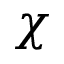Convert formula to latex. <formula><loc_0><loc_0><loc_500><loc_500>\chi</formula> 